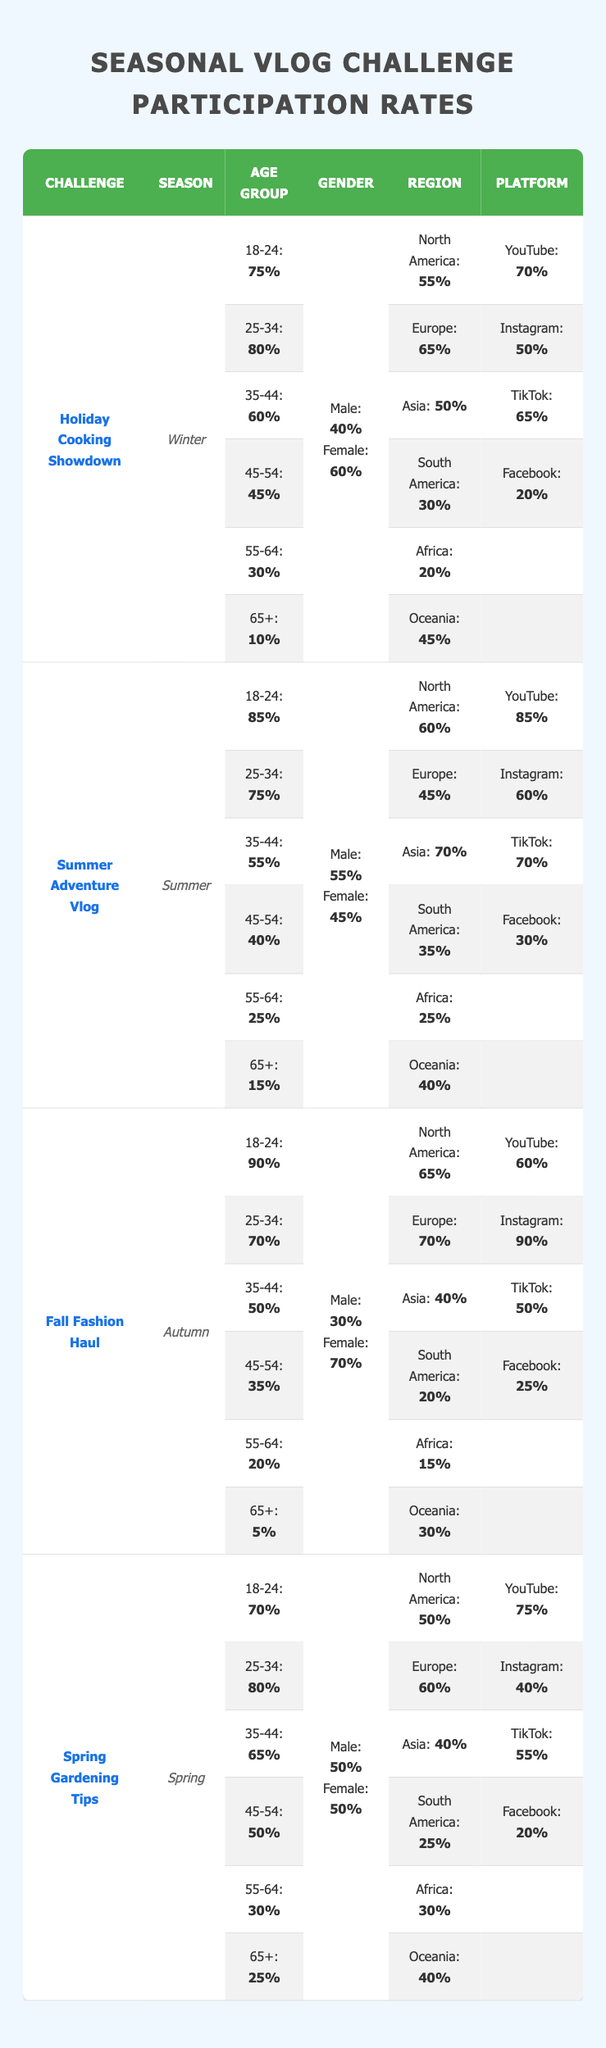What's the participation rate for the "Fall Fashion Haul" challenge among the 18-24 age group? The table shows that for the "Fall Fashion Haul" challenge, the participation rate for the 18-24 age group is 90%.
Answer: 90% Which region has the highest participation rate for the "Summer Adventure Vlog"? Looking at the table, the "Summer Adventure Vlog" has the highest participation rate in Asia at 70%.
Answer: Asia (70%) What is the average participation rate for genders across all challenges? The male participation rates are 40%, 55%, 30%, and 50%, which average to (40 + 55 + 30 + 50) / 4 = 43.75%. The female participation rates are 60%, 45%, 70%, and 50%, which average to (60 + 45 + 70 + 50) / 4 = 56.25%. Thus, the overall average is (43.75 + 56.25) / 2 = 50%.
Answer: 50% Is the participation rate for the "Holiday Cooking Showdown" higher among men or women? The participation rate is 40% for males and 60% for females in the "Holiday Cooking Showdown," indicating that the rate is higher among women.
Answer: Yes, women have a higher participation rate What is the difference in participation rates for the 25-34 age group between the "Spring Gardening Tips" and "Holiday Cooking Showdown" challenges? In the "Spring Gardening Tips," the participation rate for the 25-34 age group is 80%, while in the "Holiday Cooking Showdown" it is 80% as well. Therefore, the difference is 80 - 80 = 0%.
Answer: 0% Which gender has the highest participation rate in the "Summer Adventure Vlog"? The table indicates that the male participation rate is 55% whereas the female rate is 45% for the "Summer Adventure Vlog." Thus, males have the highest participation rate.
Answer: Males have the highest participation rate What season had the lowest participation for the 65+ age group across all challenges? The "Fall Fashion Haul" has the lowest participation for the 65+ age group at 5%.
Answer: Autumn (Fall Fashion Haul, 5%) Which platform had the least participation rate for the "Holiday Cooking Showdown"? The table states that Facebook has the least participation rate at 20% for the "Holiday Cooking Showdown."
Answer: Facebook (20%) Calculate the total participation for the 35-44 age group across all challenges. The participation rates for the 35-44 age group are 60% (Holiday Cooking Showdown), 55% (Summer Adventure Vlog), 50% (Fall Fashion Haul), and 65% (Spring Gardening Tips). Therefore, the total is 60 + 55 + 50 + 65 = 230%.
Answer: 230% How does the participation rate of the "Fall Fashion Haul" compare to the "Spring Gardening Tips" for the 45-54 age group? The "Fall Fashion Haul" has a participation rate of 35% compared to 50% for the "Spring Gardening Tips." Thus, the "Spring Gardening Tips" has a higher rate.
Answer: "Spring Gardening Tips" is higher What is the average participation rate for the "Holiday Cooking Showdown" among all platforms? The participation rates for the platforms are 70% (YouTube), 50% (Instagram), 65% (TikTok), and 20% (Facebook). The average is calculated as (70 + 50 + 65 + 20) / 4 = 51.25%.
Answer: 51.25% 